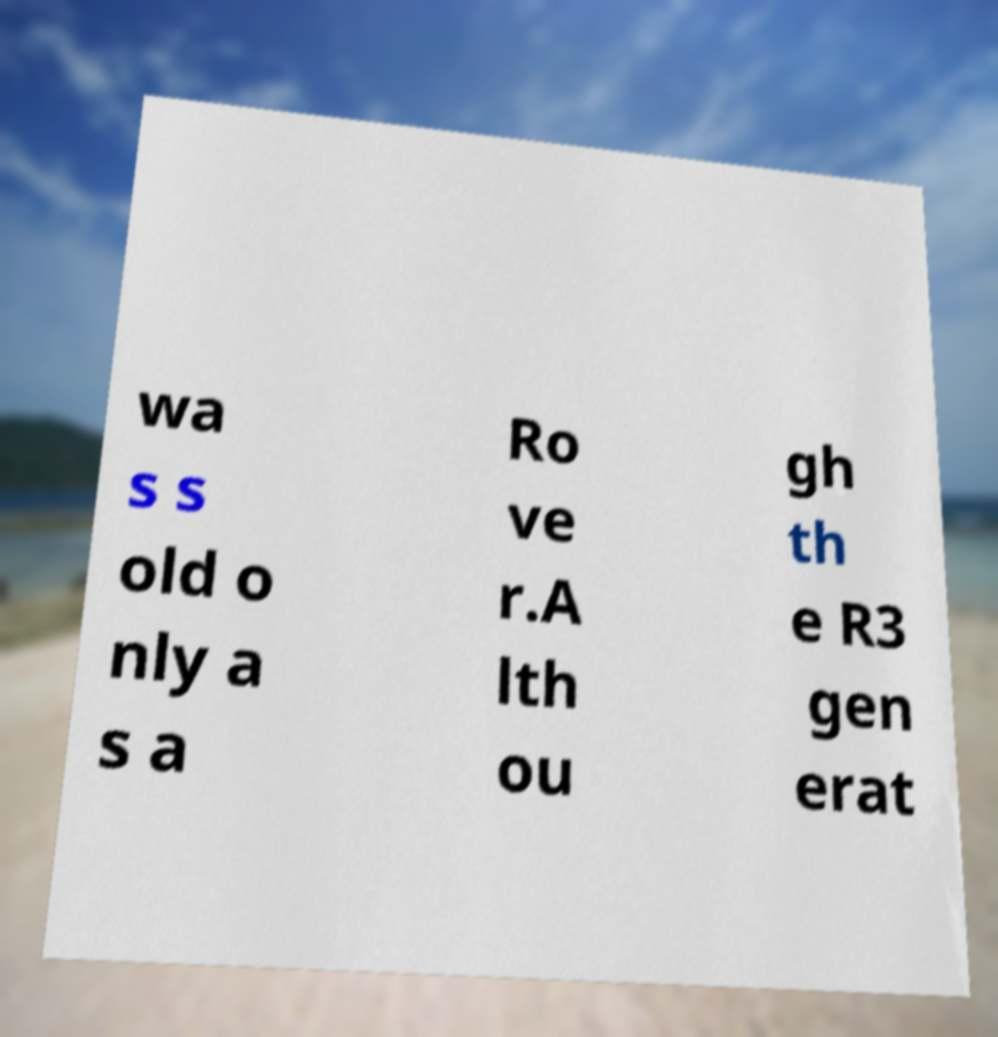Could you extract and type out the text from this image? wa s s old o nly a s a Ro ve r.A lth ou gh th e R3 gen erat 